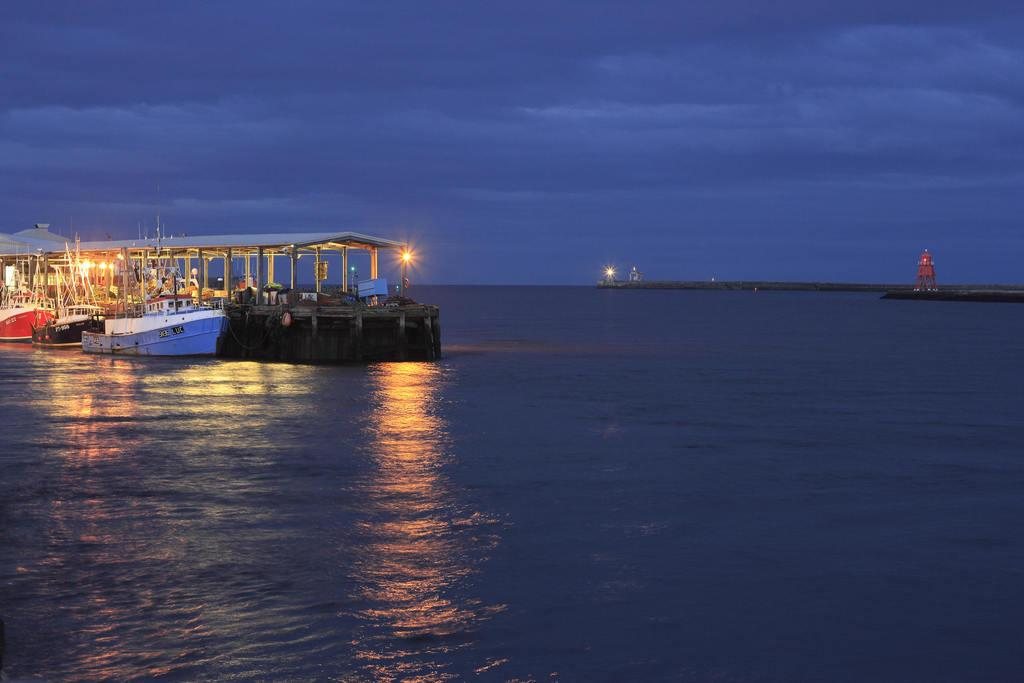What type of vehicle is present in the image? There is a boat in the image. How many other similar vehicles are in the image? There are three ships in the image. What is the common feature of the boat and ships? The boat and ships are on a water surface. What type of veil can be seen covering the boat in the image? There is no veil present in the image; the boat and ships are on a water surface without any covering. 